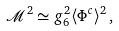Convert formula to latex. <formula><loc_0><loc_0><loc_500><loc_500>\mathcal { M } ^ { 2 } \simeq g _ { 6 } ^ { 2 } \langle \Phi ^ { c } \rangle ^ { 2 } \, ,</formula> 